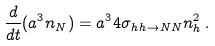<formula> <loc_0><loc_0><loc_500><loc_500>\frac { d } { d t } ( a ^ { 3 } n _ { N } ) = a ^ { 3 } 4 \sigma _ { h h \to N N } n _ { h } ^ { 2 } \, .</formula> 